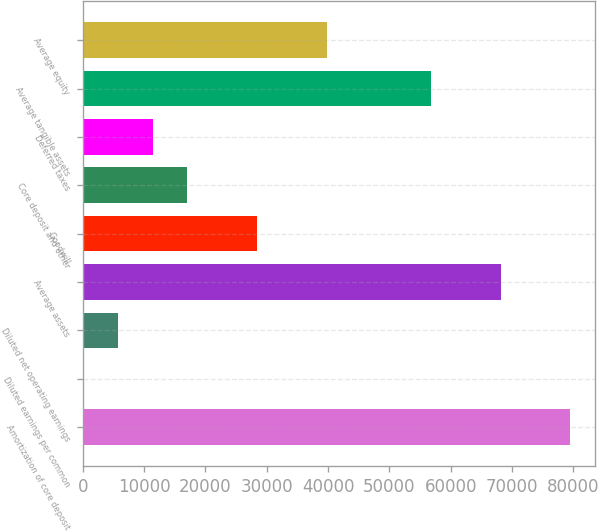Convert chart. <chart><loc_0><loc_0><loc_500><loc_500><bar_chart><fcel>Amortization of core deposit<fcel>Diluted earnings per common<fcel>Diluted net operating earnings<fcel>Average assets<fcel>Goodwill<fcel>Core deposit and other<fcel>Deferred taxes<fcel>Average tangible assets<fcel>Average equity<nl><fcel>79524.4<fcel>6.73<fcel>5686.56<fcel>68164.7<fcel>28405.9<fcel>17046.2<fcel>11366.4<fcel>56805<fcel>39765.5<nl></chart> 